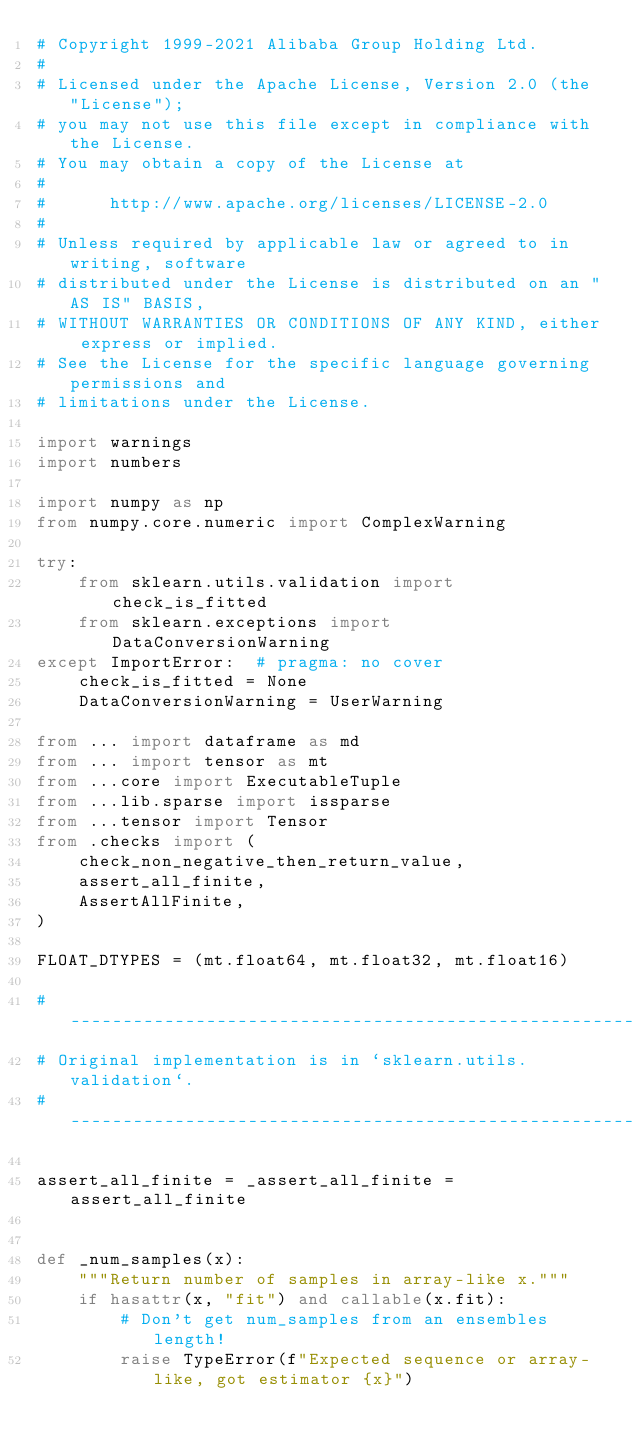<code> <loc_0><loc_0><loc_500><loc_500><_Python_># Copyright 1999-2021 Alibaba Group Holding Ltd.
#
# Licensed under the Apache License, Version 2.0 (the "License");
# you may not use this file except in compliance with the License.
# You may obtain a copy of the License at
#
#      http://www.apache.org/licenses/LICENSE-2.0
#
# Unless required by applicable law or agreed to in writing, software
# distributed under the License is distributed on an "AS IS" BASIS,
# WITHOUT WARRANTIES OR CONDITIONS OF ANY KIND, either express or implied.
# See the License for the specific language governing permissions and
# limitations under the License.

import warnings
import numbers

import numpy as np
from numpy.core.numeric import ComplexWarning

try:
    from sklearn.utils.validation import check_is_fitted
    from sklearn.exceptions import DataConversionWarning
except ImportError:  # pragma: no cover
    check_is_fitted = None
    DataConversionWarning = UserWarning

from ... import dataframe as md
from ... import tensor as mt
from ...core import ExecutableTuple
from ...lib.sparse import issparse
from ...tensor import Tensor
from .checks import (
    check_non_negative_then_return_value,
    assert_all_finite,
    AssertAllFinite,
)

FLOAT_DTYPES = (mt.float64, mt.float32, mt.float16)

# ---------------------------------------------------------
# Original implementation is in `sklearn.utils.validation`.
# ---------------------------------------------------------

assert_all_finite = _assert_all_finite = assert_all_finite


def _num_samples(x):
    """Return number of samples in array-like x."""
    if hasattr(x, "fit") and callable(x.fit):
        # Don't get num_samples from an ensembles length!
        raise TypeError(f"Expected sequence or array-like, got estimator {x}")</code> 